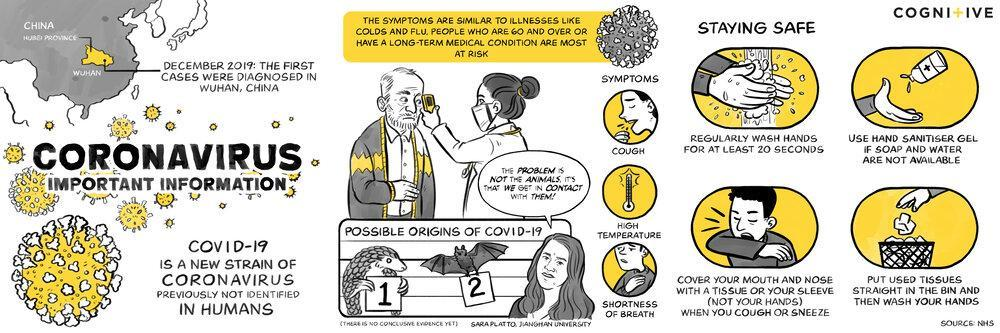What are the common symptoms of COVID-19?
Answer the question with a short phrase. COUGH, HIGH TEMPERATURE, SHORTNESS OF BREATH 